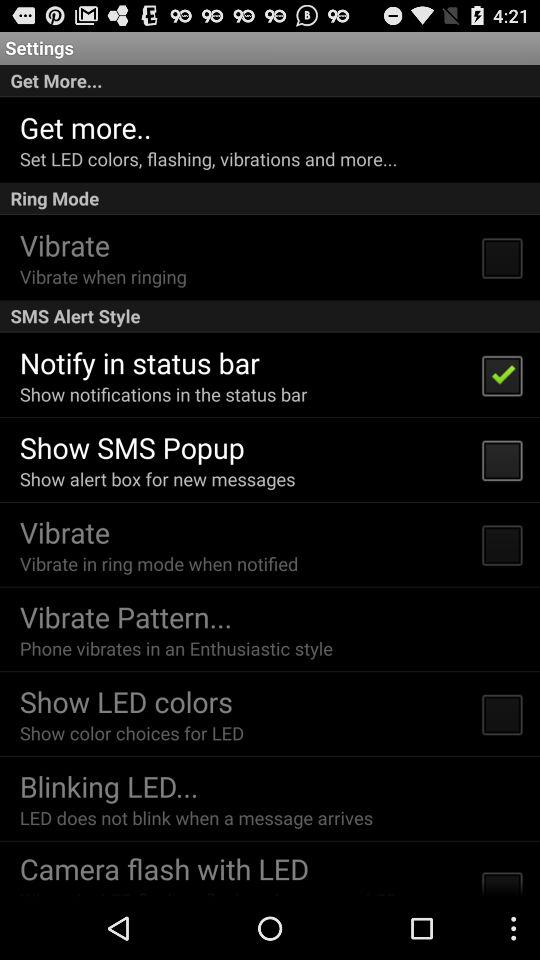What is the current status of the "Show SMS Popup"? The current status of the "Show SMS Popup" is "off". 